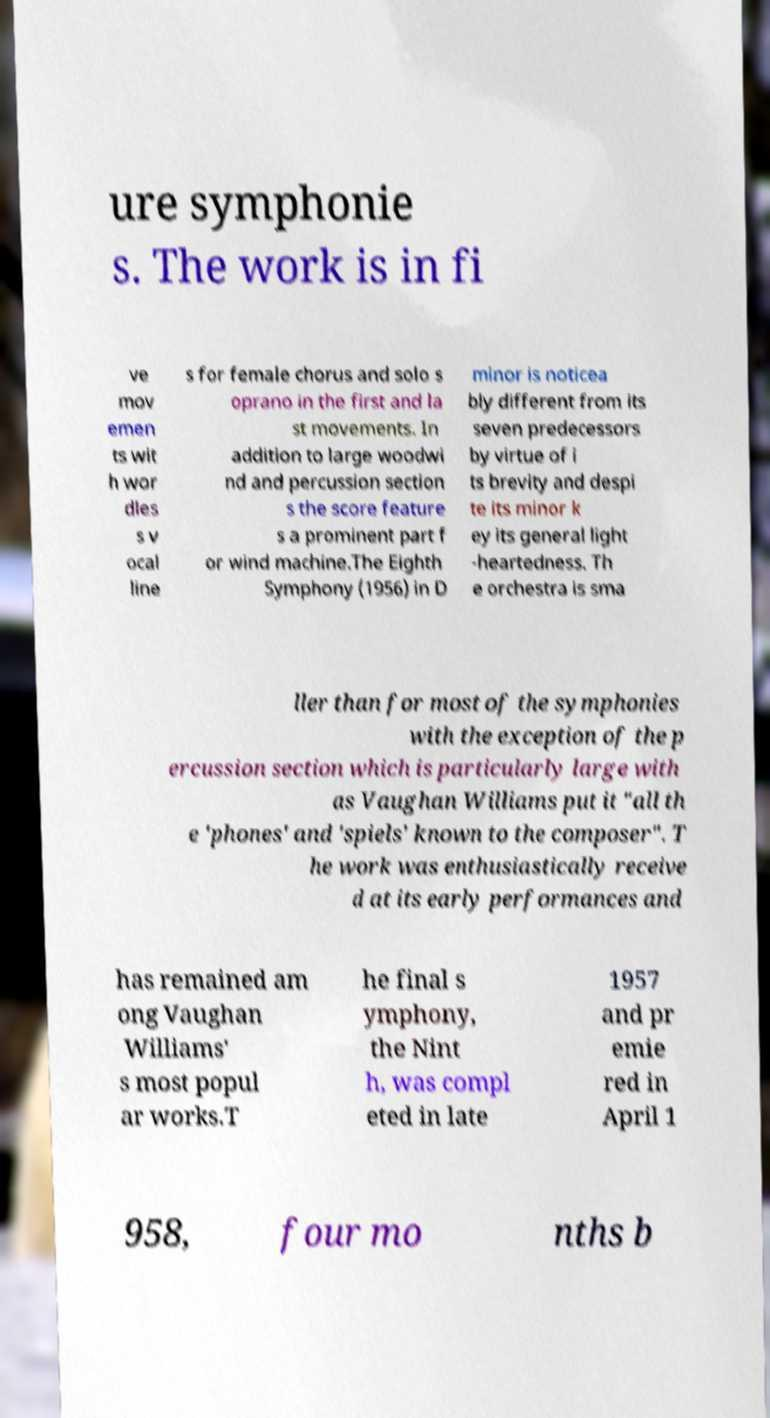Please read and relay the text visible in this image. What does it say? ure symphonie s. The work is in fi ve mov emen ts wit h wor dles s v ocal line s for female chorus and solo s oprano in the first and la st movements. In addition to large woodwi nd and percussion section s the score feature s a prominent part f or wind machine.The Eighth Symphony (1956) in D minor is noticea bly different from its seven predecessors by virtue of i ts brevity and despi te its minor k ey its general light -heartedness. Th e orchestra is sma ller than for most of the symphonies with the exception of the p ercussion section which is particularly large with as Vaughan Williams put it "all th e 'phones' and 'spiels' known to the composer". T he work was enthusiastically receive d at its early performances and has remained am ong Vaughan Williams' s most popul ar works.T he final s ymphony, the Nint h, was compl eted in late 1957 and pr emie red in April 1 958, four mo nths b 